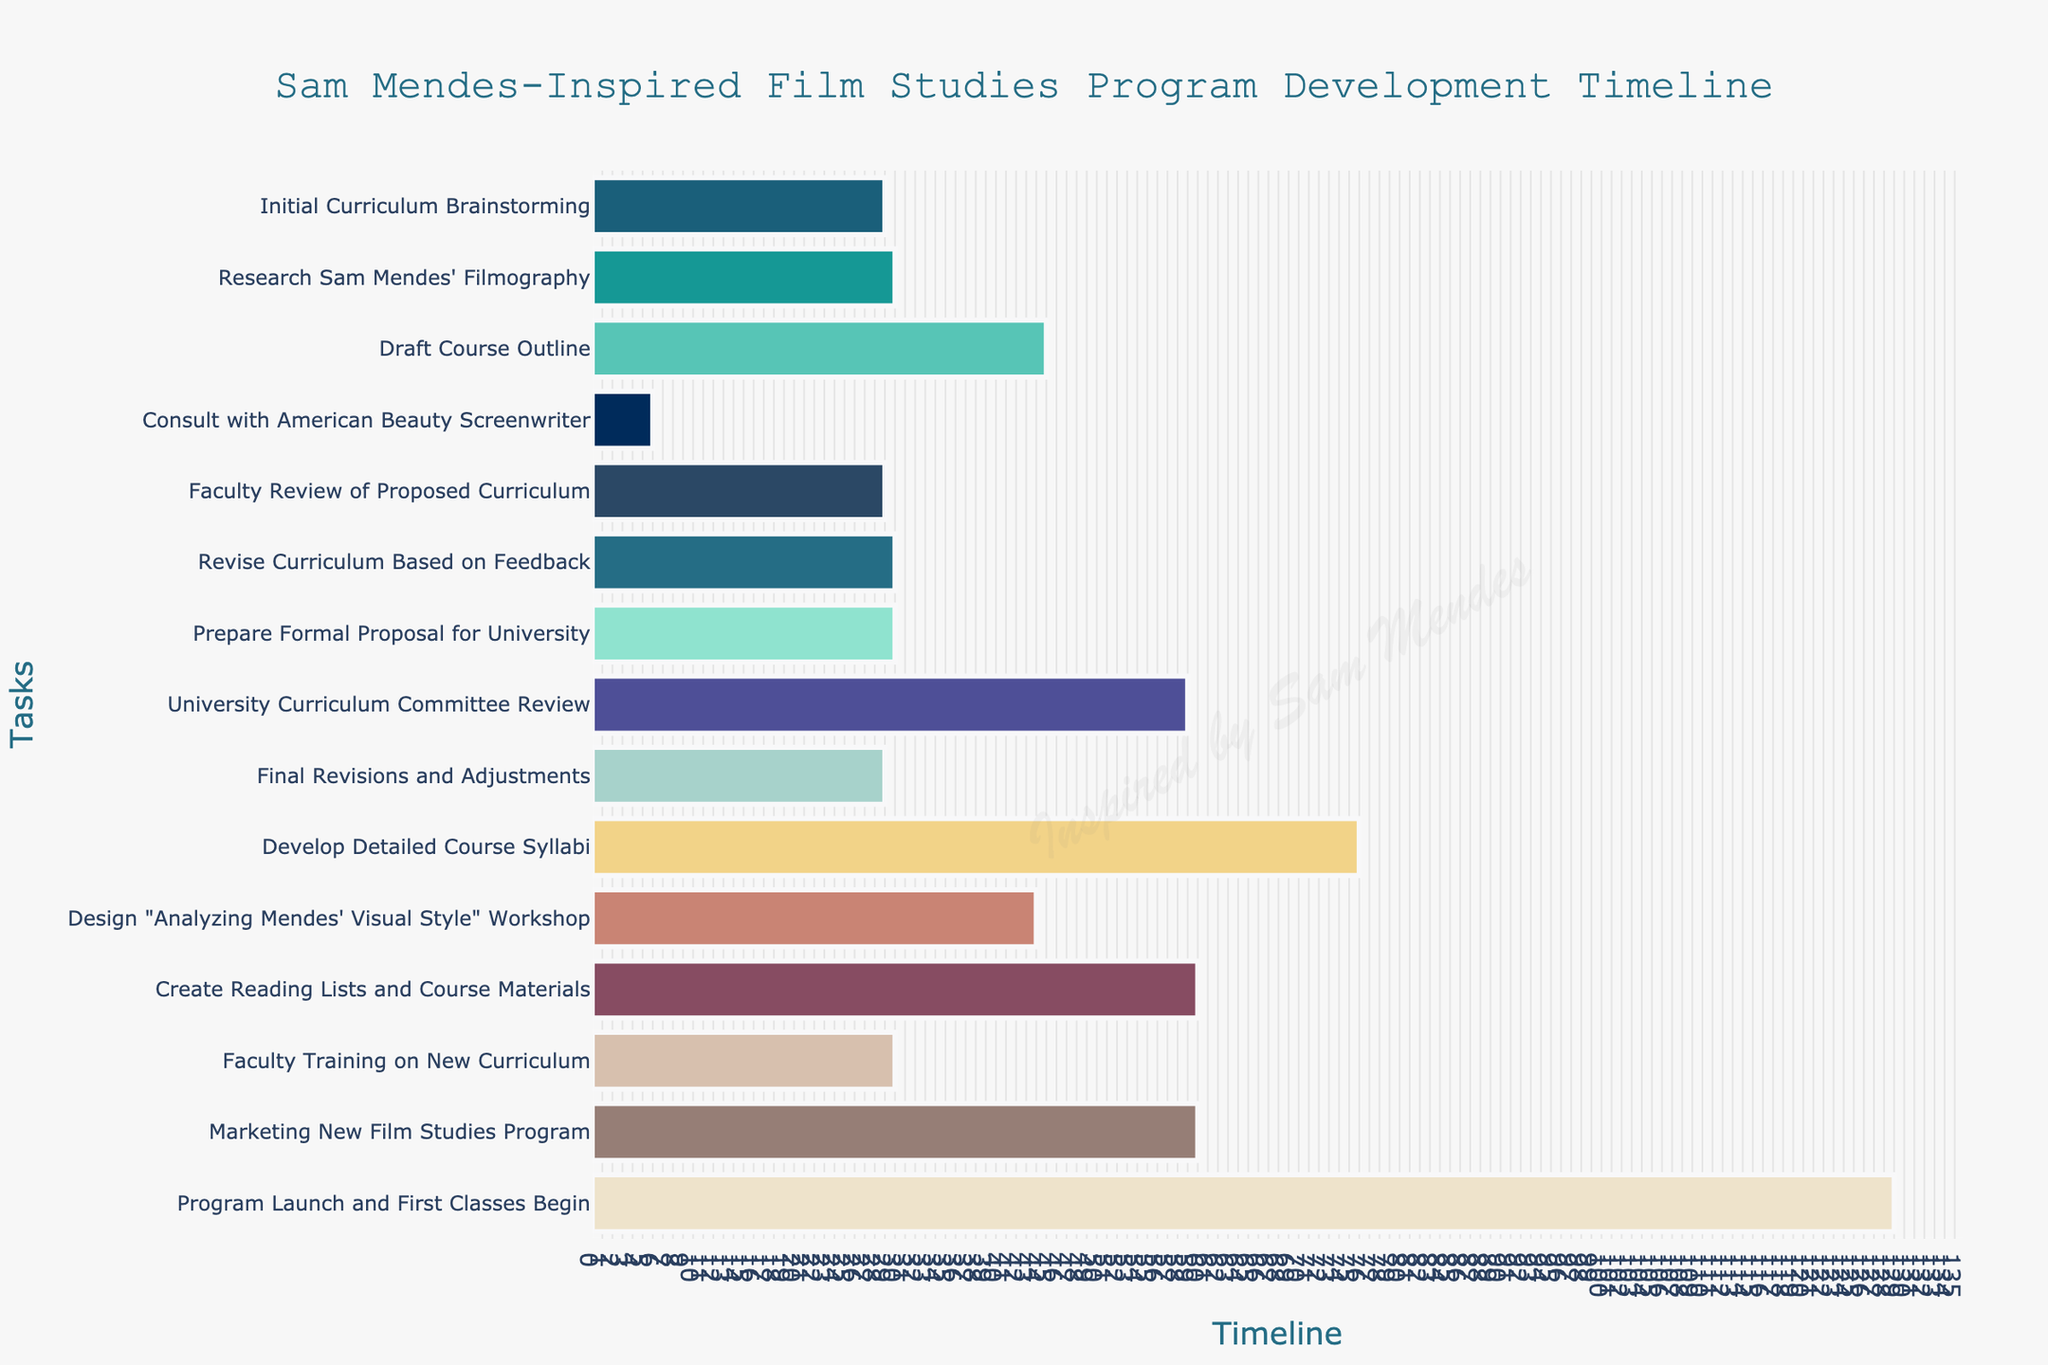When does the "Initial Curriculum Brainstorming" task start and end? The "Initial Curriculum Brainstorming" task begins on September 1, 2023, and ends on September 30, 2023, as shown by the start and end dates on the Gantt chart.
Answer: September 1, 2023 - September 30, 2023 How long is the "Draft Course Outline" task? To determine the duration of the "Draft Course Outline" task, we look at the start and end dates: October 1, 2023, to November 15, 2023. The difference is calculated as 45 days.
Answer: 45 days Which task ends the latest in the timeline? By visually scanning the Gantt chart, the task "Program Launch and First Classes Begin" has the latest end date of May 15, 2025.
Answer: "Program Launch and First Classes Begin" What is the total duration for consulting with the "American Beauty Screenwriter" task? This task starts on November 1, 2023, and ends on November 7, 2023, making the total duration 7 days.
Answer: 7 days Which tasks overlap with "Revise Curriculum Based on Feedback"? The "Revise Curriculum Based on Feedback" task runs from December 16, 2023, to January 15, 2024. Overlapping tasks are "Prepare Formal Proposal for University" (starts January 16) and "Faculty Review of Proposed Curriculum" (ends Dec 15).
Answer: None What is the sequence of tasks starting from "Research Sam Mendes' Filmography"? Referring to the chart, the sequence starting from "Research Sam Mendes' Filmography" is: 
"Research Sam Mendes' Filmography" → "Draft Course Outline" → "Consult with American Beauty Screenwriter"
Answer: Research Sam Mendes' Filmography → Draft Course Outline → Consult with American Beauty Screenwriter Which task has the shortest duration and what is it? The shortest task on the Gantt chart is "Consult with American Beauty Screenwriter," which takes 7 days.
Answer: "Consult with American Beauty Screenwriter" How does the duration of "Prepare Formal Proposal for University" compare to "Faculty Training on New Curriculum"? "Prepare Formal Proposal for University" runs for 31 days from January 16 to February 15, 2024. "Faculty Training on New Curriculum" runs for 31 days from October 1 to October 31, 2024. Both tasks have an equal duration.
Answer: Equal Explain the overlap in tasks during June 2024. During June 2024, there are two overlapping tasks: "Develop Detailed Course Syllabi" and "Design 'Analyzing Mendes' Visual Style' Workshop." The latter starts on June 1, 2024, and ends on July 15, 2024, while the former runs from May 16, 2024, to July 31, 2024.
Answer: "Develop Detailed Course Syllabi" and "Design 'Analyzing Mendes' Visual Style' Workshop" What is the longest single task in the project, and how long does it last? On the Gantt chart, the longest task is "Program Launch and First Classes Begin," lasting 130 days from January 6, 2025, to May 15, 2025.
Answer: "Program Launch and First Classes Begin" (130 days) 